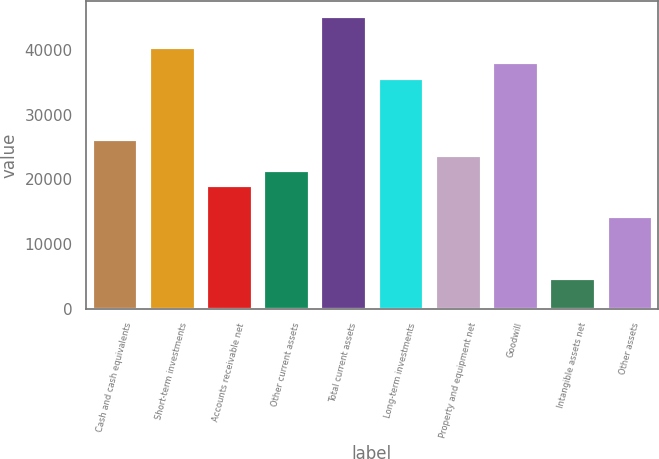Convert chart to OTSL. <chart><loc_0><loc_0><loc_500><loc_500><bar_chart><fcel>Cash and cash equivalents<fcel>Short-term investments<fcel>Accounts receivable net<fcel>Other current assets<fcel>Total current assets<fcel>Long-term investments<fcel>Property and equipment net<fcel>Goodwill<fcel>Intangible assets net<fcel>Other assets<nl><fcel>26231.5<fcel>40538.5<fcel>19078<fcel>21462.5<fcel>45307.5<fcel>35769.5<fcel>23847<fcel>38154<fcel>4771<fcel>14309<nl></chart> 